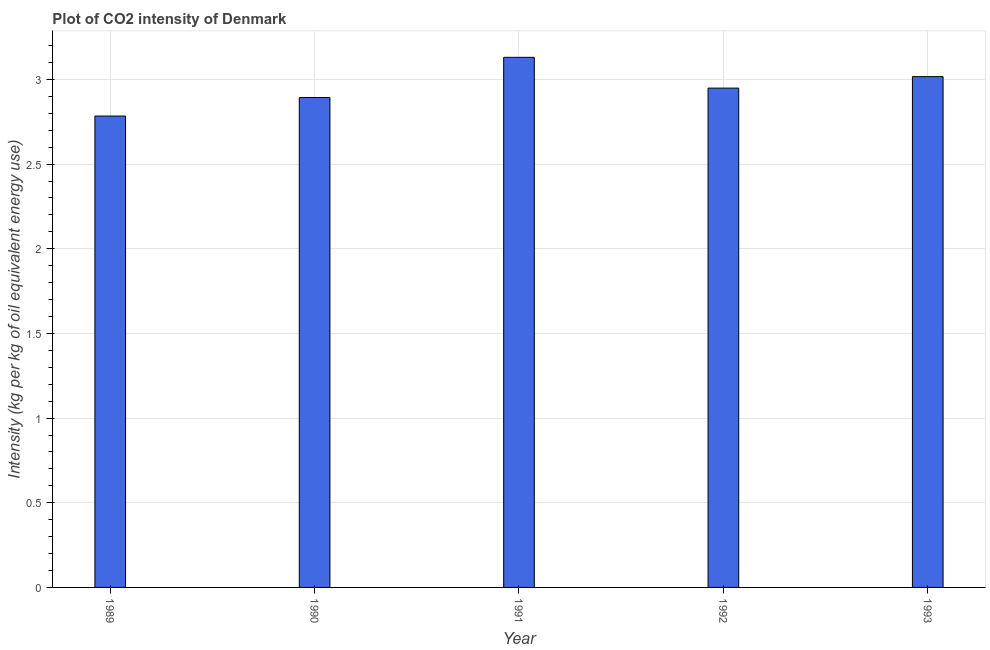Does the graph contain grids?
Ensure brevity in your answer.  Yes. What is the title of the graph?
Your response must be concise. Plot of CO2 intensity of Denmark. What is the label or title of the X-axis?
Provide a succinct answer. Year. What is the label or title of the Y-axis?
Your answer should be very brief. Intensity (kg per kg of oil equivalent energy use). What is the co2 intensity in 1990?
Your answer should be compact. 2.89. Across all years, what is the maximum co2 intensity?
Provide a succinct answer. 3.13. Across all years, what is the minimum co2 intensity?
Keep it short and to the point. 2.78. In which year was the co2 intensity maximum?
Provide a short and direct response. 1991. In which year was the co2 intensity minimum?
Provide a short and direct response. 1989. What is the sum of the co2 intensity?
Provide a short and direct response. 14.77. What is the difference between the co2 intensity in 1989 and 1990?
Your response must be concise. -0.11. What is the average co2 intensity per year?
Provide a succinct answer. 2.96. What is the median co2 intensity?
Make the answer very short. 2.95. Do a majority of the years between 1991 and 1990 (inclusive) have co2 intensity greater than 0.2 kg?
Give a very brief answer. No. What is the ratio of the co2 intensity in 1990 to that in 1991?
Give a very brief answer. 0.92. Is the co2 intensity in 1990 less than that in 1991?
Your answer should be compact. Yes. What is the difference between the highest and the second highest co2 intensity?
Offer a very short reply. 0.11. In how many years, is the co2 intensity greater than the average co2 intensity taken over all years?
Your answer should be compact. 2. How many years are there in the graph?
Provide a short and direct response. 5. What is the difference between two consecutive major ticks on the Y-axis?
Your answer should be compact. 0.5. What is the Intensity (kg per kg of oil equivalent energy use) of 1989?
Give a very brief answer. 2.78. What is the Intensity (kg per kg of oil equivalent energy use) of 1990?
Provide a short and direct response. 2.89. What is the Intensity (kg per kg of oil equivalent energy use) of 1991?
Your answer should be compact. 3.13. What is the Intensity (kg per kg of oil equivalent energy use) in 1992?
Offer a terse response. 2.95. What is the Intensity (kg per kg of oil equivalent energy use) of 1993?
Your answer should be compact. 3.02. What is the difference between the Intensity (kg per kg of oil equivalent energy use) in 1989 and 1990?
Your answer should be very brief. -0.11. What is the difference between the Intensity (kg per kg of oil equivalent energy use) in 1989 and 1991?
Make the answer very short. -0.35. What is the difference between the Intensity (kg per kg of oil equivalent energy use) in 1989 and 1992?
Provide a succinct answer. -0.17. What is the difference between the Intensity (kg per kg of oil equivalent energy use) in 1989 and 1993?
Your answer should be very brief. -0.23. What is the difference between the Intensity (kg per kg of oil equivalent energy use) in 1990 and 1991?
Offer a terse response. -0.24. What is the difference between the Intensity (kg per kg of oil equivalent energy use) in 1990 and 1992?
Provide a short and direct response. -0.06. What is the difference between the Intensity (kg per kg of oil equivalent energy use) in 1990 and 1993?
Your answer should be compact. -0.12. What is the difference between the Intensity (kg per kg of oil equivalent energy use) in 1991 and 1992?
Offer a very short reply. 0.18. What is the difference between the Intensity (kg per kg of oil equivalent energy use) in 1991 and 1993?
Your answer should be very brief. 0.11. What is the difference between the Intensity (kg per kg of oil equivalent energy use) in 1992 and 1993?
Your answer should be compact. -0.07. What is the ratio of the Intensity (kg per kg of oil equivalent energy use) in 1989 to that in 1990?
Offer a terse response. 0.96. What is the ratio of the Intensity (kg per kg of oil equivalent energy use) in 1989 to that in 1991?
Your response must be concise. 0.89. What is the ratio of the Intensity (kg per kg of oil equivalent energy use) in 1989 to that in 1992?
Your answer should be very brief. 0.94. What is the ratio of the Intensity (kg per kg of oil equivalent energy use) in 1989 to that in 1993?
Your answer should be compact. 0.92. What is the ratio of the Intensity (kg per kg of oil equivalent energy use) in 1990 to that in 1991?
Provide a short and direct response. 0.92. What is the ratio of the Intensity (kg per kg of oil equivalent energy use) in 1990 to that in 1992?
Give a very brief answer. 0.98. What is the ratio of the Intensity (kg per kg of oil equivalent energy use) in 1990 to that in 1993?
Ensure brevity in your answer.  0.96. What is the ratio of the Intensity (kg per kg of oil equivalent energy use) in 1991 to that in 1992?
Provide a short and direct response. 1.06. What is the ratio of the Intensity (kg per kg of oil equivalent energy use) in 1991 to that in 1993?
Ensure brevity in your answer.  1.04. What is the ratio of the Intensity (kg per kg of oil equivalent energy use) in 1992 to that in 1993?
Your answer should be very brief. 0.98. 